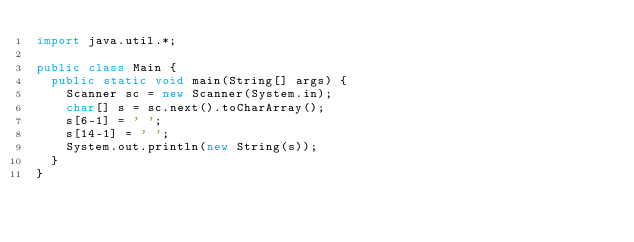<code> <loc_0><loc_0><loc_500><loc_500><_Java_>import java.util.*;

public class Main {
  public static void main(String[] args) {
    Scanner sc = new Scanner(System.in);
    char[] s = sc.next().toCharArray();
    s[6-1] = ' ';
    s[14-1] = ' ';
    System.out.println(new String(s));
  }
}</code> 